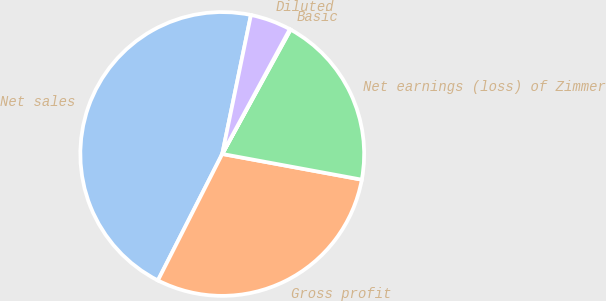Convert chart. <chart><loc_0><loc_0><loc_500><loc_500><pie_chart><fcel>Net sales<fcel>Gross profit<fcel>Net earnings (loss) of Zimmer<fcel>Basic<fcel>Diluted<nl><fcel>45.75%<fcel>29.59%<fcel>19.9%<fcel>0.1%<fcel>4.66%<nl></chart> 